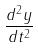<formula> <loc_0><loc_0><loc_500><loc_500>\frac { d ^ { 2 } y } { d t ^ { 2 } }</formula> 